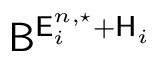Convert formula to latex. <formula><loc_0><loc_0><loc_500><loc_500>B ^ { E _ { i } ^ { n , ^ { * } } + H _ { i } }</formula> 